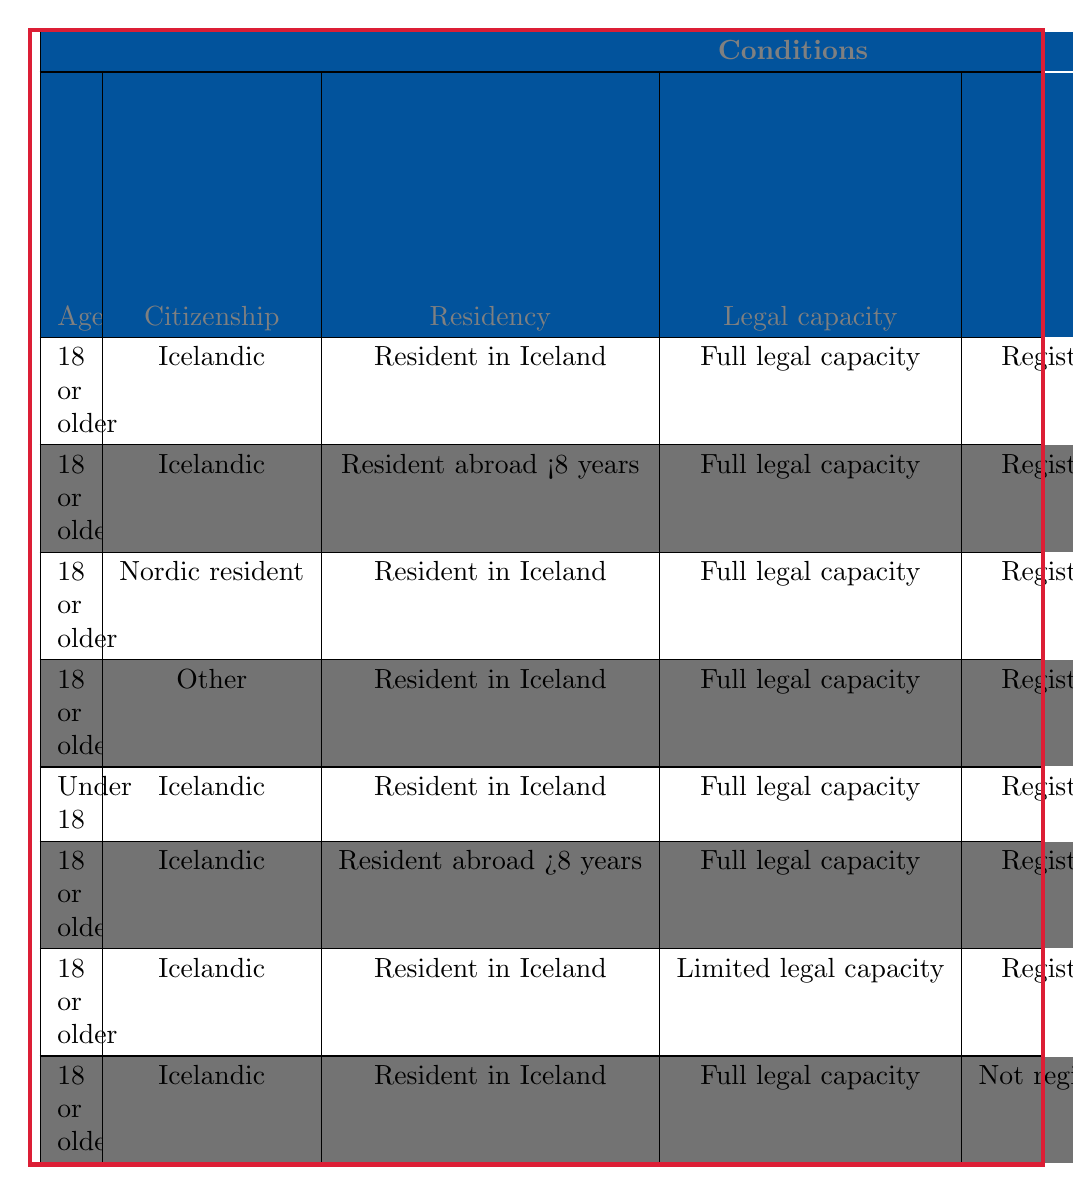What is the eligibility for national elections if someone is 18 or older, holds Icelandic citizenship, resides in Iceland, has full legal capacity, and is registered in the National Registry? According to rule 1 in the table, these conditions result in eligibility for national elections marked as "Yes."
Answer: Yes Can a Nordic resident who is 18 or older and resides in Iceland vote in national elections? Looking at rule 3, a Nordic resident who meets these criteria is marked as "No" for eligibility in national elections.
Answer: No What are the conditions for a voter to be eligible to vote in local elections while living abroad for less than 8 years? Referring to rule 2, the conditions are 18 or older, Icelandic citizenship, living abroad for less than 8 years, full legal capacity, and registered in the National Registry, leading to eligibility in local elections.
Answer: Yes Is a person under 18 years old eligible to vote in local elections if they meet all other conditions? Rule 5 indicates that individuals under 18 are not eligible for local elections, regardless of their other conditions.
Answer: No If someone is Icelandic, lives abroad for more than 8 years with full legal capacity, and is registered in the National Registry, do they need to register separately? Rule 6 confirms that individuals with these conditions do need to register separately, indicated by a "Yes" for separate registration.
Answer: Yes How many scenarios are there in which an Icelandic citizen living in Iceland is ineligible for national elections? By examining rules 5, 6, 7, and 8, we see four scenarios where an Icelandic citizen residing in Iceland does not qualify for national elections.
Answer: Four What is the total number of unique voter eligibility scenarios for Icelandic elections presented in the table? The table lists 8 distinct rules, each representing a unique scenario regarding voter eligibility criteria.
Answer: Eight If a person is 18 years old, holds Icelandic citizenship, has limited legal capacity, and resides in Iceland, can they vote in local elections? Referencing rule 7, such a person is marked as ineligible to vote in local elections, therefore the answer is "No."
Answer: No Do individuals who are registered in the National Registry but have limited legal capacity qualify to vote in any election? According to rule 7, individuals with limited legal capacity do not qualify to vote in either national or local elections.
Answer: No 